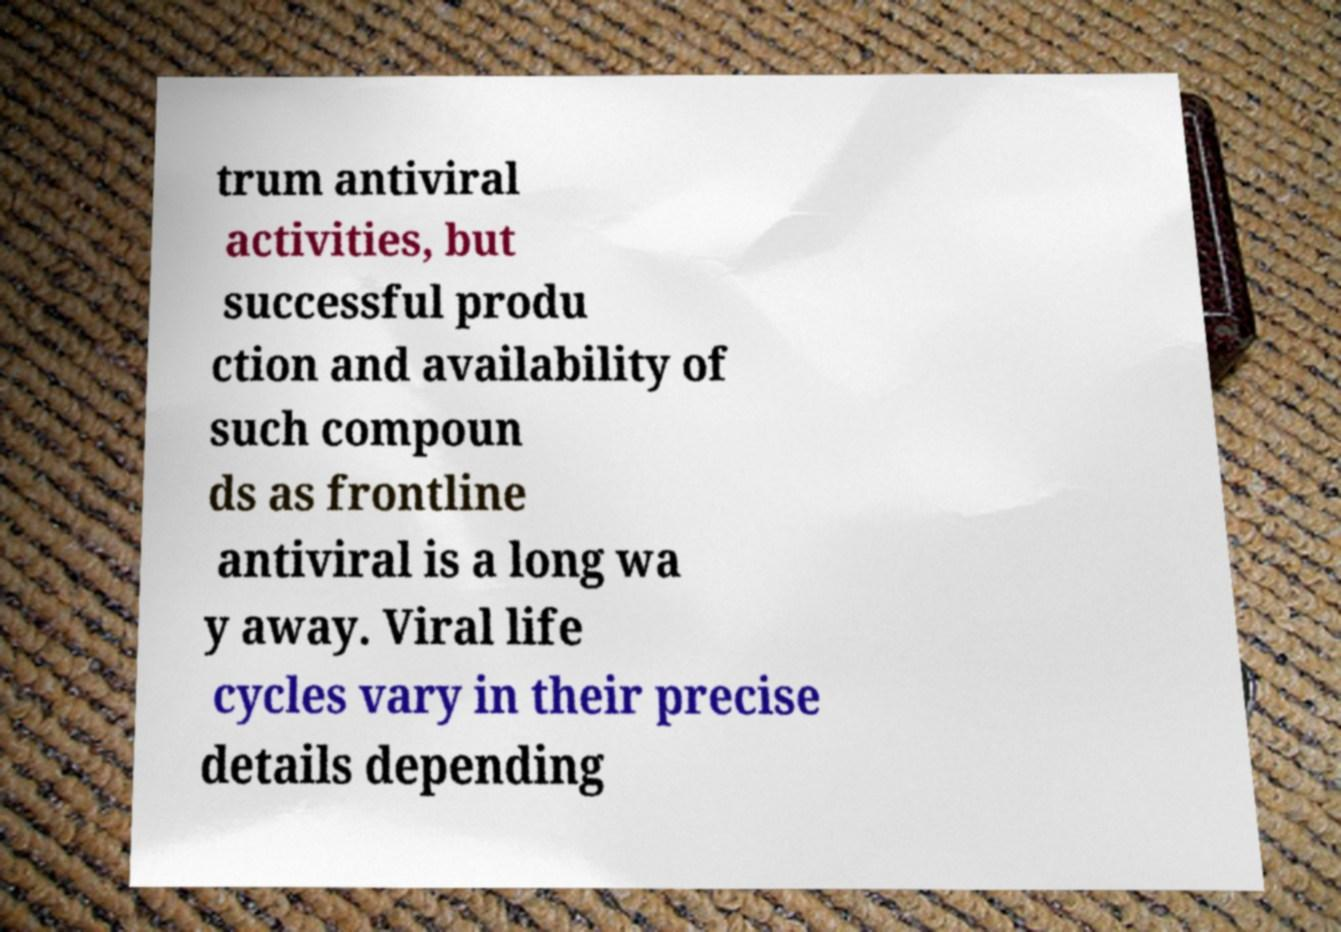Could you assist in decoding the text presented in this image and type it out clearly? trum antiviral activities, but successful produ ction and availability of such compoun ds as frontline antiviral is a long wa y away. Viral life cycles vary in their precise details depending 